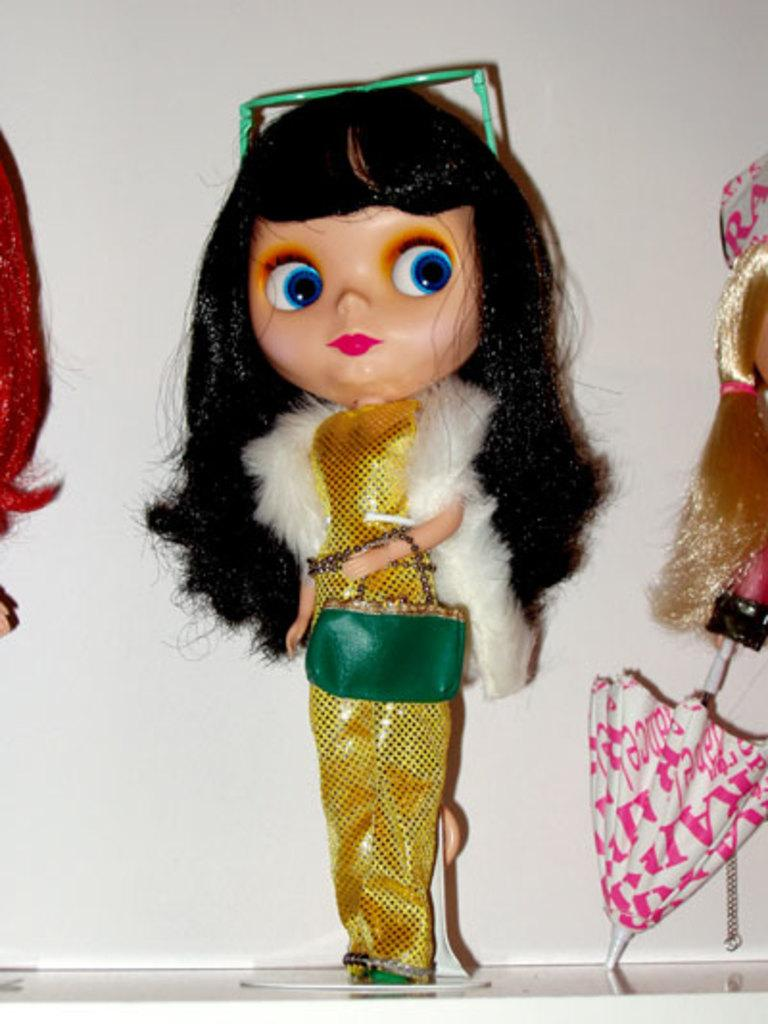What type of objects are present in the image? There are dolls in the image. Can you describe the dolls in the image? The dolls are of different types. What type of school can be seen in the image? There is no school present in the image; it features dolls of different types. What is the value of the deer in the image? There is no deer present in the image, so it is not possible to determine its value. 